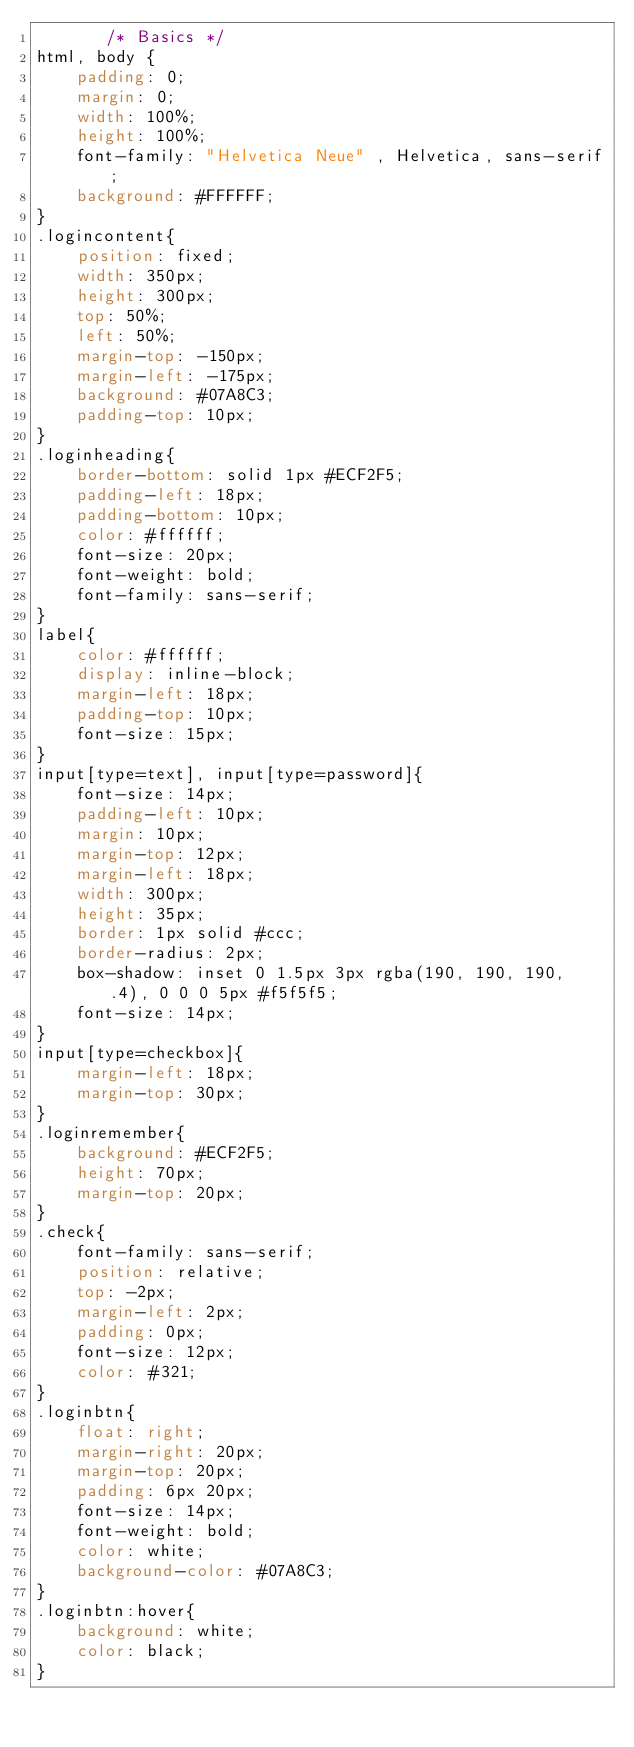<code> <loc_0><loc_0><loc_500><loc_500><_CSS_>       /* Basics */
html, body {
    padding: 0;
    margin: 0;
    width: 100%;
    height: 100%;
    font-family: "Helvetica Neue" , Helvetica, sans-serif;
    background: #FFFFFF;
}
.logincontent{
    position: fixed;
    width: 350px;
    height: 300px;
    top: 50%;
    left: 50%;
    margin-top: -150px;
    margin-left: -175px;
    background: #07A8C3;
    padding-top: 10px;
}
.loginheading{
    border-bottom: solid 1px #ECF2F5;
    padding-left: 18px;
    padding-bottom: 10px;
    color: #ffffff;
    font-size: 20px;
    font-weight: bold;
    font-family: sans-serif;
}
label{
    color: #ffffff;
    display: inline-block;
    margin-left: 18px;
    padding-top: 10px;
    font-size: 15px;
}
input[type=text], input[type=password]{
    font-size: 14px;
    padding-left: 10px;
    margin: 10px;
    margin-top: 12px;
    margin-left: 18px;
    width: 300px;
    height: 35px;
    border: 1px solid #ccc;
    border-radius: 2px;
    box-shadow: inset 0 1.5px 3px rgba(190, 190, 190,   .4), 0 0 0 5px #f5f5f5;
    font-size: 14px;
}
input[type=checkbox]{
    margin-left: 18px;
    margin-top: 30px;
}
.loginremember{
    background: #ECF2F5;
    height: 70px;
    margin-top: 20px;
}
.check{
    font-family: sans-serif;
    position: relative;
    top: -2px;
    margin-left: 2px;
    padding: 0px;
    font-size: 12px;
    color: #321;
}
.loginbtn{
    float: right;
    margin-right: 20px;
    margin-top: 20px;
    padding: 6px 20px;
    font-size: 14px;
    font-weight: bold;
    color: white;
    background-color: #07A8C3;
}
.loginbtn:hover{
    background: white;
    color: black;
}
    </code> 